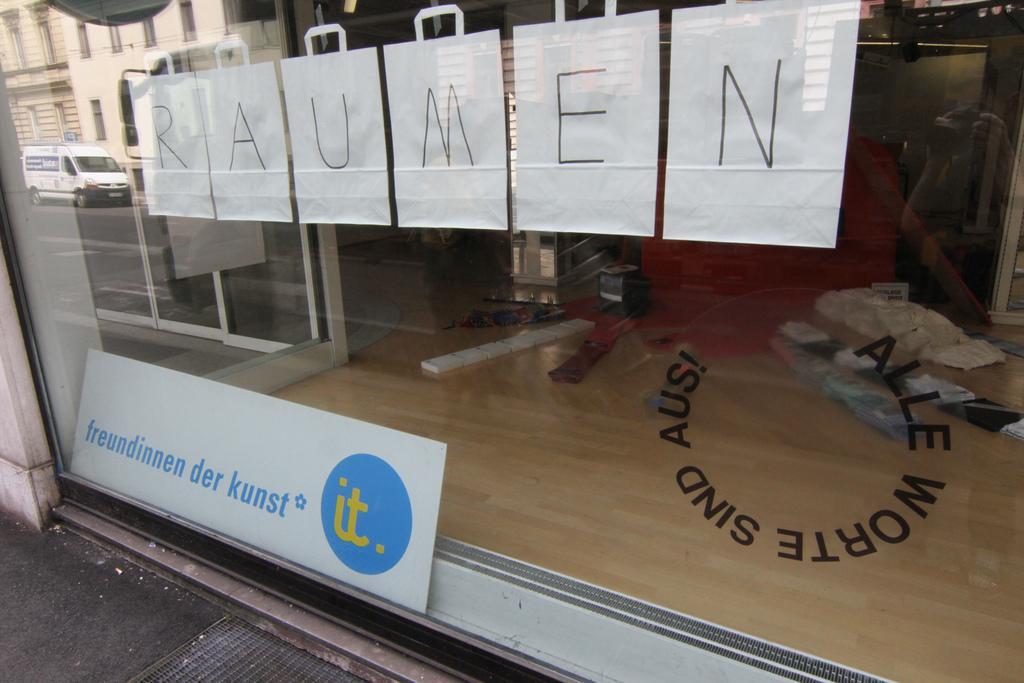Describe this image in one or two sentences. There is a glass wall. On that something is pasted. Near to that there is a poster. On that we can see a reflection of a building and a vehicle. Through the glass we can see many things. 